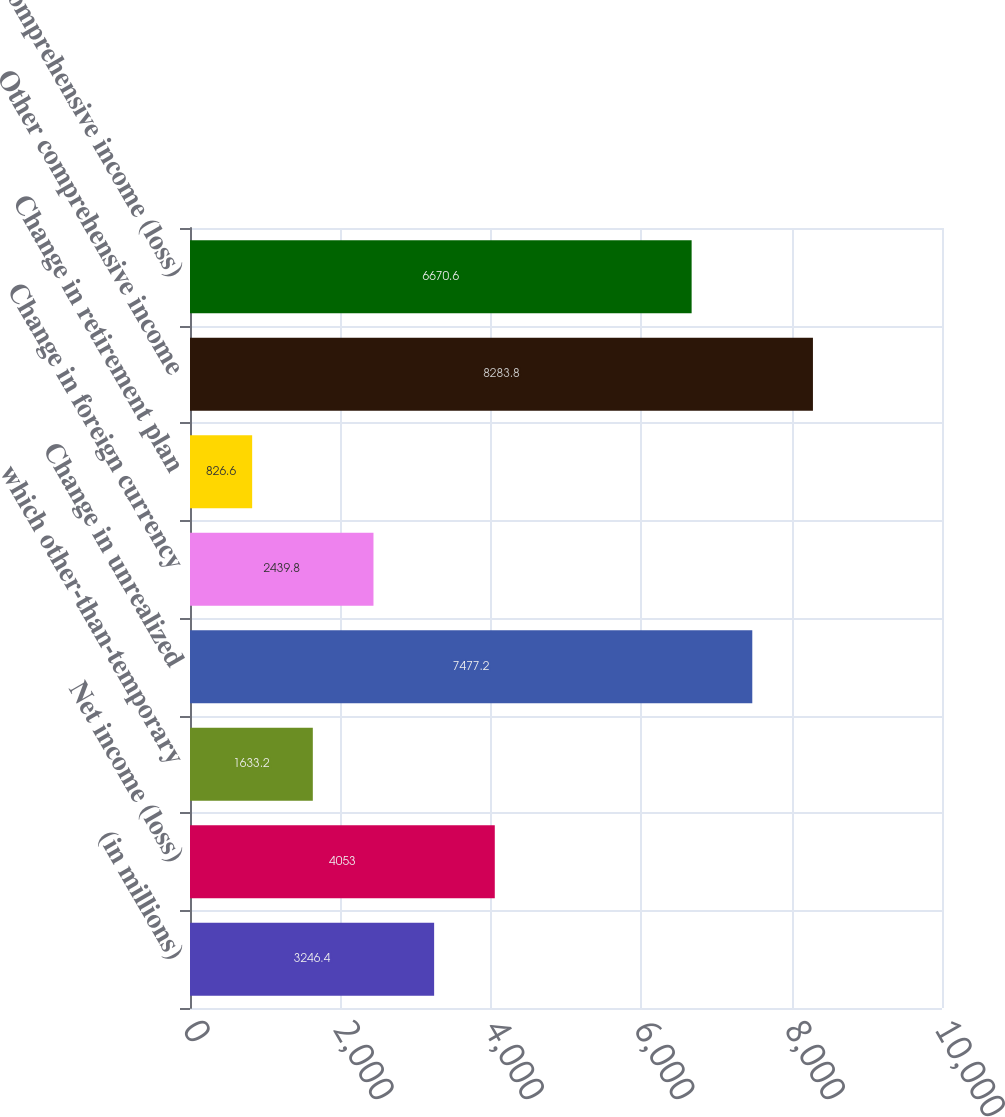Convert chart. <chart><loc_0><loc_0><loc_500><loc_500><bar_chart><fcel>(in millions)<fcel>Net income (loss)<fcel>which other-than-temporary<fcel>Change in unrealized<fcel>Change in foreign currency<fcel>Change in retirement plan<fcel>Other comprehensive income<fcel>Comprehensive income (loss)<nl><fcel>3246.4<fcel>4053<fcel>1633.2<fcel>7477.2<fcel>2439.8<fcel>826.6<fcel>8283.8<fcel>6670.6<nl></chart> 